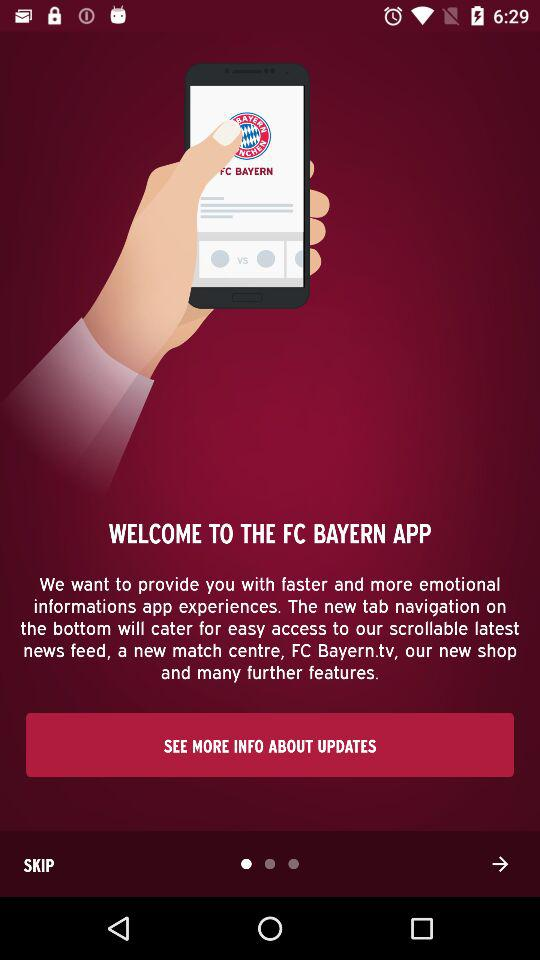What is the app name? The app name is "FC BAYERN". 